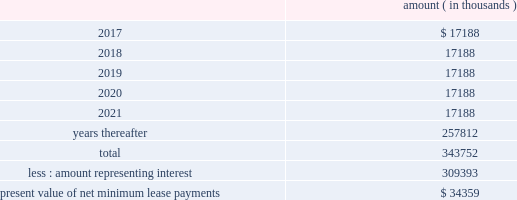Entergy corporation and subsidiaries notes to financial statements liability to $ 60 million , and recorded the $ 2.7 million difference as a credit to interest expense .
The $ 60 million remaining liability was eliminated upon payment of the cash portion of the purchase price .
As of december 31 , 2016 , entergy louisiana , in connection with the waterford 3 lease obligation , had a future minimum lease payment ( reflecting an interest rate of 8.09% ( 8.09 % ) ) of $ 57.5 million , including $ 2.3 million in interest , due january 2017 that is recorded as long-term debt .
In february 2017 the leases were terminated and the leased assets were conveyed to entergy louisiana .
Grand gulf lease obligations in 1988 , in two separate but substantially identical transactions , system energy sold and leased back undivided ownership interests in grand gulf for the aggregate sum of $ 500 million .
The initial term of the leases expired in july 2015 .
System energy renewed the leases for fair market value with renewal terms expiring in july 2036 .
At the end of the new lease renewal terms , system energy has the option to repurchase the leased interests in grand gulf or renew the leases at fair market value .
In the event that system energy does not renew or purchase the interests , system energy would surrender such interests and their associated entitlement of grand gulf 2019s capacity and energy .
System energy is required to report the sale-leaseback as a financing transaction in its financial statements .
For financial reporting purposes , system energy expenses the interest portion of the lease obligation and the plant depreciation .
However , operating revenues include the recovery of the lease payments because the transactions are accounted for as a sale and leaseback for ratemaking purposes .
Consistent with a recommendation contained in a ferc audit report , system energy initially recorded as a net regulatory asset the difference between the recovery of the lease payments and the amounts expensed for interest and depreciation and continues to record this difference as a regulatory asset or liability on an ongoing basis , resulting in a zero net balance for the regulatory asset at the end of the lease term .
The amount was a net regulatory liability of $ 55.6 million and $ 55.6 million as of december 31 , 2016 and 2015 , respectively .
As of december 31 , 2016 , system energy , in connection with the grand gulf sale and leaseback transactions , had future minimum lease payments ( reflecting an implicit rate of 5.13% ( 5.13 % ) ) that are recorded as long-term debt , as follows : amount ( in thousands ) .

What portion of the total future minimum lease payment for entergy louisiana will be used for interest payments? 
Computations: (2.3 / 57.5)
Answer: 0.04. 